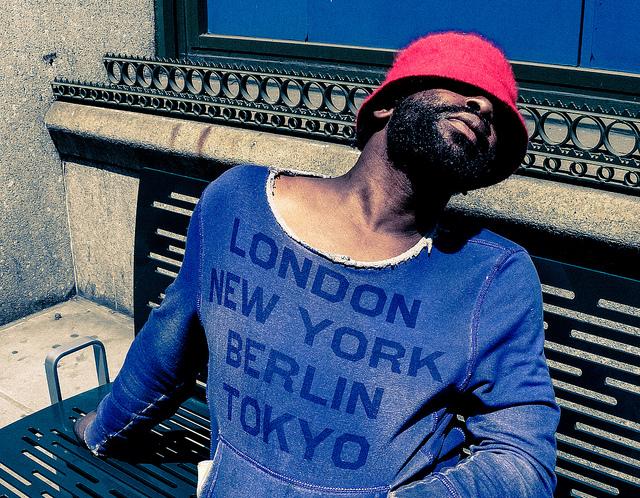What cities do you think this guy likes?
Be succinct. London, new york, berlin, tokyo. What is the man holding?
Short answer required. Nothing. What color is the man's shirt?
Quick response, please. Blue. 